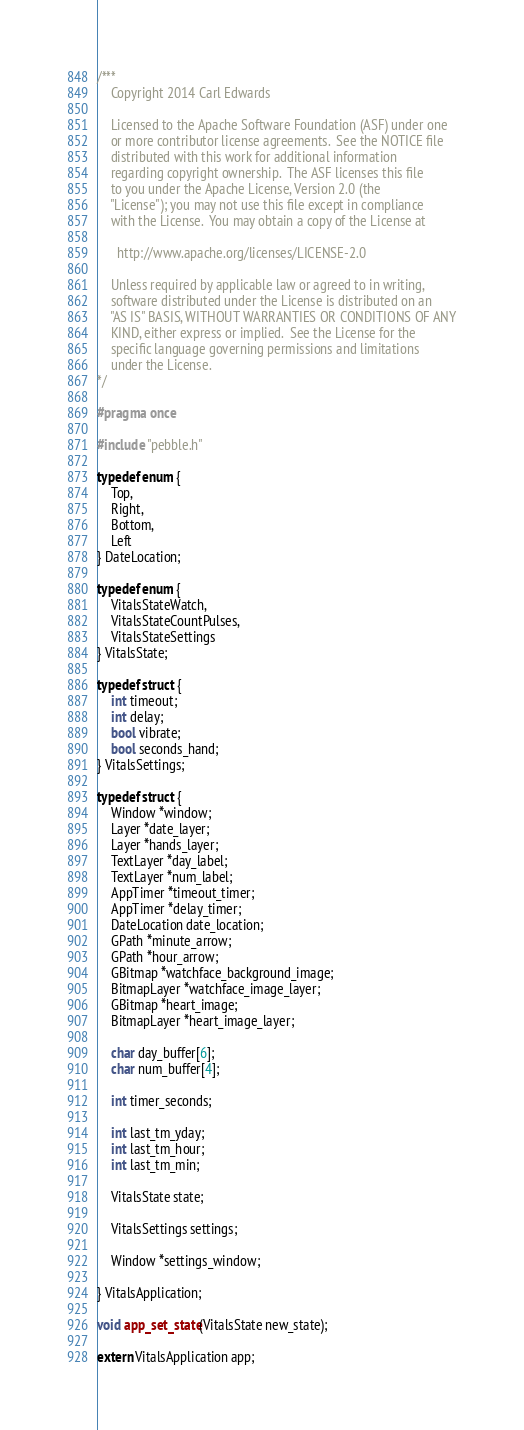Convert code to text. <code><loc_0><loc_0><loc_500><loc_500><_C_>/***
    Copyright 2014 Carl Edwards

    Licensed to the Apache Software Foundation (ASF) under one
    or more contributor license agreements.  See the NOTICE file
    distributed with this work for additional information
    regarding copyright ownership.  The ASF licenses this file
    to you under the Apache License, Version 2.0 (the
    "License"); you may not use this file except in compliance
    with the License.  You may obtain a copy of the License at

      http://www.apache.org/licenses/LICENSE-2.0

    Unless required by applicable law or agreed to in writing,
    software distributed under the License is distributed on an
    "AS IS" BASIS, WITHOUT WARRANTIES OR CONDITIONS OF ANY
    KIND, either express or implied.  See the License for the
    specific language governing permissions and limitations
    under the License.
*/

#pragma once

#include "pebble.h"

typedef enum {
    Top,
    Right,
    Bottom,
    Left
} DateLocation;

typedef enum {
    VitalsStateWatch,
    VitalsStateCountPulses,
    VitalsStateSettings
} VitalsState;

typedef struct {
    int timeout;
    int delay;
    bool vibrate;
    bool seconds_hand;
} VitalsSettings;

typedef struct {
    Window *window;
    Layer *date_layer;
    Layer *hands_layer;
    TextLayer *day_label;
    TextLayer *num_label;
    AppTimer *timeout_timer;
    AppTimer *delay_timer;
    DateLocation date_location;
    GPath *minute_arrow;
    GPath *hour_arrow;
    GBitmap *watchface_background_image;
    BitmapLayer *watchface_image_layer;
    GBitmap *heart_image;
    BitmapLayer *heart_image_layer;

    char day_buffer[6];
    char num_buffer[4];

    int timer_seconds;

    int last_tm_yday;
    int last_tm_hour;
    int last_tm_min;

    VitalsState state;
    
    VitalsSettings settings;

    Window *settings_window;

} VitalsApplication;

void app_set_state(VitalsState new_state);

extern VitalsApplication app;</code> 